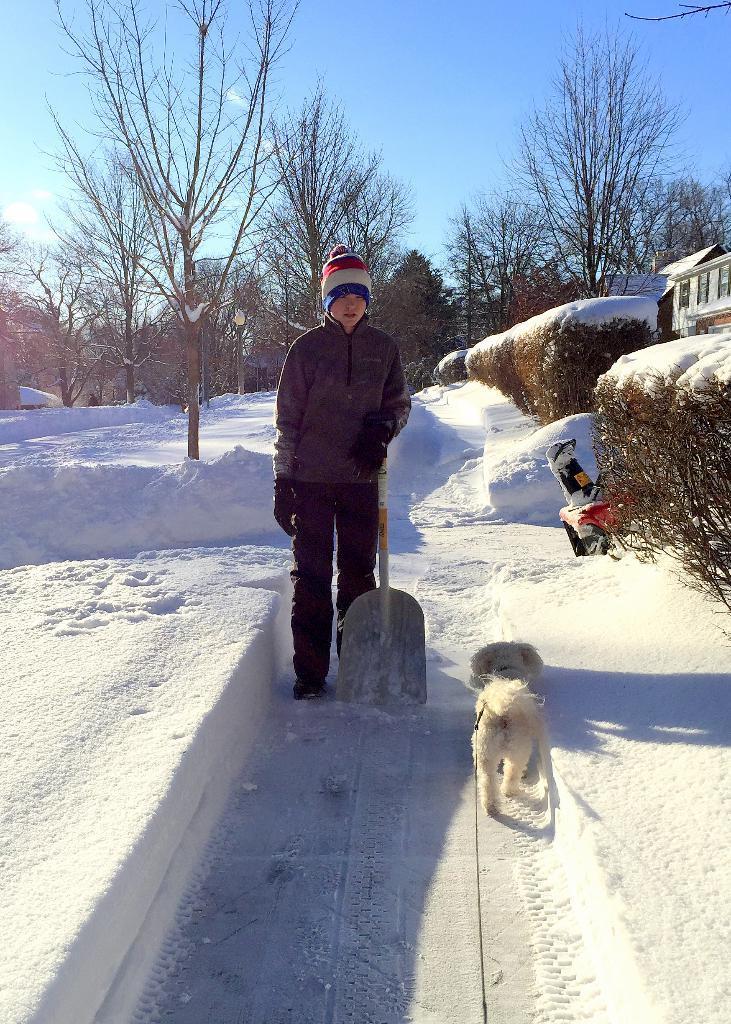How would you summarize this image in a sentence or two? In the image there is boy standing in the middle with a shovel and dog in front of him on the snow land and there are plants on either side of the path with a building on the right side corner and above its sky. 